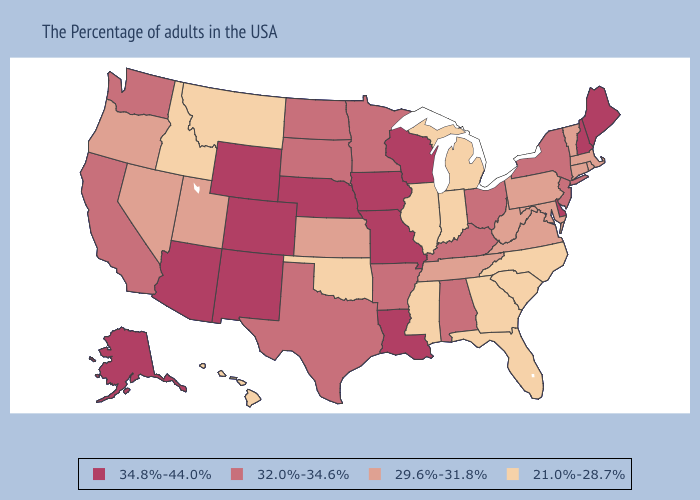Does Utah have the same value as Kansas?
Give a very brief answer. Yes. Name the states that have a value in the range 34.8%-44.0%?
Give a very brief answer. Maine, New Hampshire, Delaware, Wisconsin, Louisiana, Missouri, Iowa, Nebraska, Wyoming, Colorado, New Mexico, Arizona, Alaska. Among the states that border Missouri , does Oklahoma have the lowest value?
Answer briefly. Yes. Does Iowa have the highest value in the MidWest?
Answer briefly. Yes. What is the value of Wyoming?
Write a very short answer. 34.8%-44.0%. What is the highest value in the South ?
Answer briefly. 34.8%-44.0%. What is the value of Kentucky?
Quick response, please. 32.0%-34.6%. What is the lowest value in the USA?
Quick response, please. 21.0%-28.7%. What is the value of Indiana?
Answer briefly. 21.0%-28.7%. Name the states that have a value in the range 29.6%-31.8%?
Quick response, please. Massachusetts, Rhode Island, Vermont, Connecticut, Maryland, Pennsylvania, Virginia, West Virginia, Tennessee, Kansas, Utah, Nevada, Oregon. Does Arizona have the highest value in the West?
Short answer required. Yes. Name the states that have a value in the range 29.6%-31.8%?
Keep it brief. Massachusetts, Rhode Island, Vermont, Connecticut, Maryland, Pennsylvania, Virginia, West Virginia, Tennessee, Kansas, Utah, Nevada, Oregon. What is the highest value in the USA?
Short answer required. 34.8%-44.0%. Does South Carolina have the highest value in the South?
Write a very short answer. No. What is the value of Arkansas?
Be succinct. 32.0%-34.6%. 